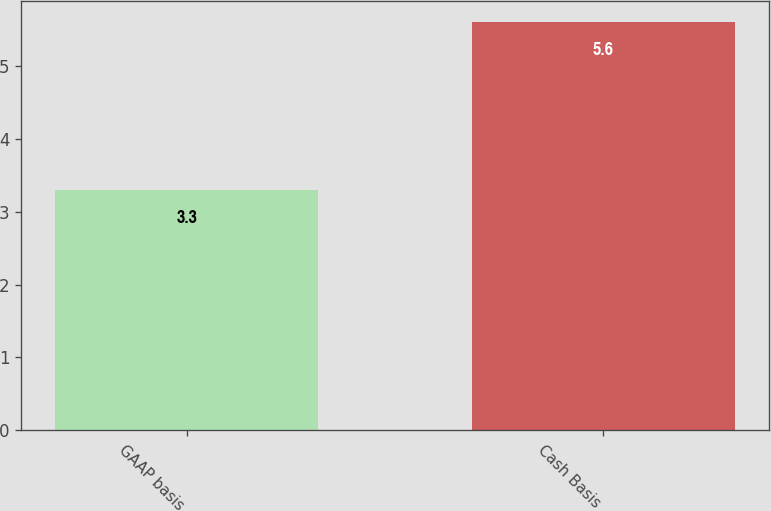<chart> <loc_0><loc_0><loc_500><loc_500><bar_chart><fcel>GAAP basis<fcel>Cash Basis<nl><fcel>3.3<fcel>5.6<nl></chart> 